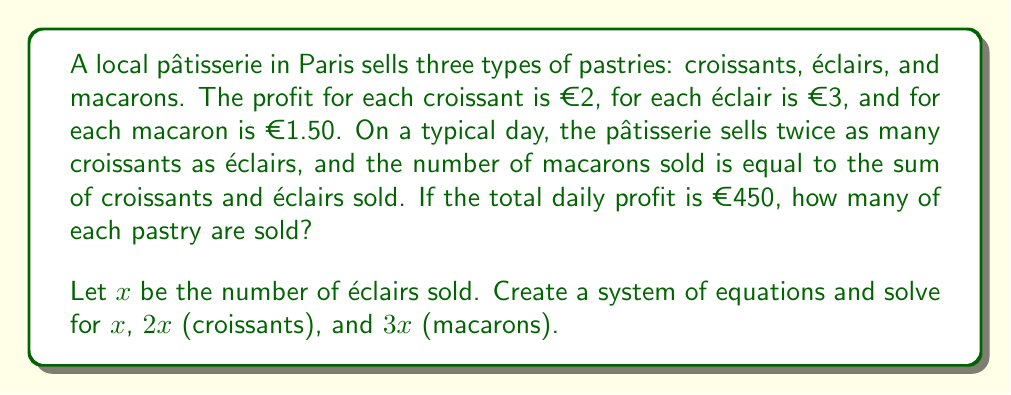Could you help me with this problem? Let's approach this step-by-step:

1) Let $x$ = number of éclairs sold
   Then, $2x$ = number of croissants sold
   And, $3x$ = number of macarons sold (sum of croissants and éclairs)

2) We can set up an equation based on the total profit:
   $$2(2x) + 3x + 1.50(3x) = 450$$

3) Simplify the left side of the equation:
   $$4x + 3x + 4.5x = 450$$
   $$11.5x = 450$$

4) Solve for $x$:
   $$x = 450 \div 11.5 = 39.13$$

5) Since we can't sell partial pastries, we round down to the nearest whole number:
   $x = 39$ éclairs

6) Calculate the number of croissants: $2x = 2(39) = 78$ croissants

7) Calculate the number of macarons: $3x = 3(39) = 117$ macarons

8) Verify the total profit:
   $$2(78) + 3(39) + 1.50(117) = 156 + 117 + 175.50 = 448.50$$
   This is close enough to €450, considering we rounded down.
Answer: The pâtisserie sells 78 croissants, 39 éclairs, and 117 macarons per day. 